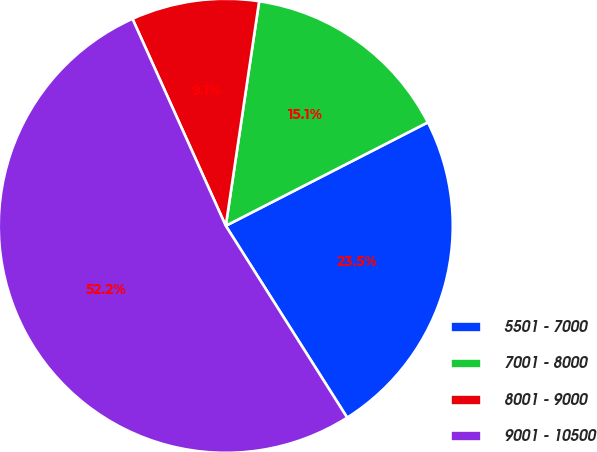Convert chart to OTSL. <chart><loc_0><loc_0><loc_500><loc_500><pie_chart><fcel>5501 - 7000<fcel>7001 - 8000<fcel>8001 - 9000<fcel>9001 - 10500<nl><fcel>23.55%<fcel>15.12%<fcel>9.09%<fcel>52.24%<nl></chart> 